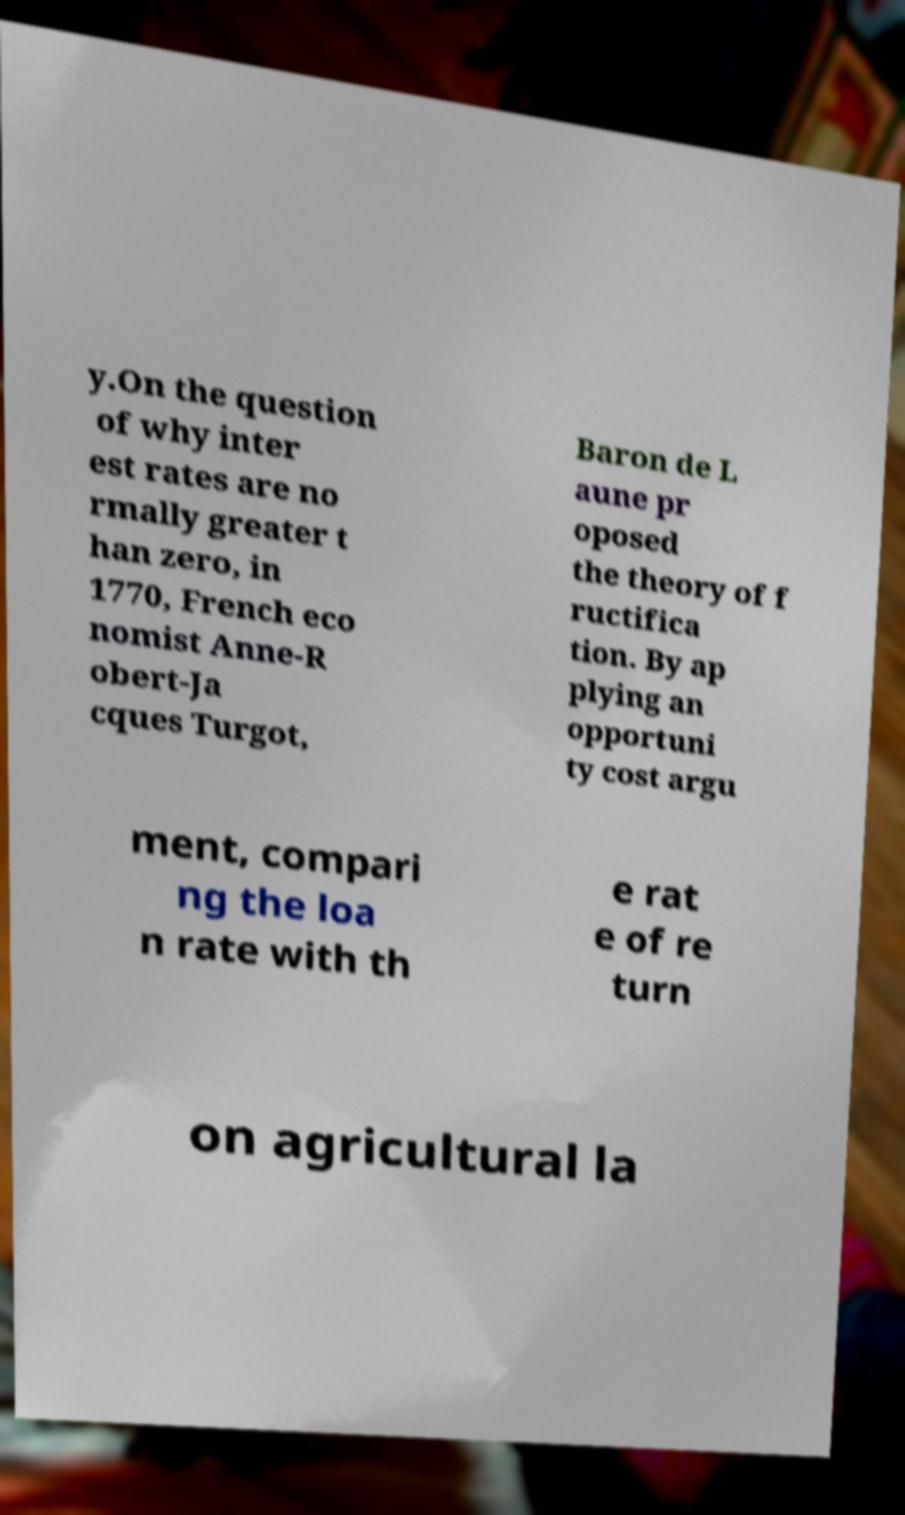Could you assist in decoding the text presented in this image and type it out clearly? y.On the question of why inter est rates are no rmally greater t han zero, in 1770, French eco nomist Anne-R obert-Ja cques Turgot, Baron de L aune pr oposed the theory of f ructifica tion. By ap plying an opportuni ty cost argu ment, compari ng the loa n rate with th e rat e of re turn on agricultural la 